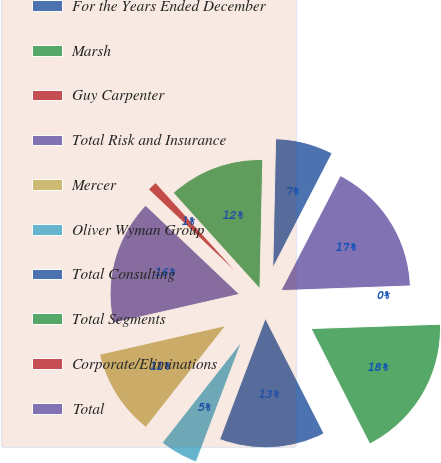Convert chart. <chart><loc_0><loc_0><loc_500><loc_500><pie_chart><fcel>For the Years Ended December<fcel>Marsh<fcel>Guy Carpenter<fcel>Total Risk and Insurance<fcel>Mercer<fcel>Oliver Wyman Group<fcel>Total Consulting<fcel>Total Segments<fcel>Corporate/Eliminations<fcel>Total<nl><fcel>7.24%<fcel>12.04%<fcel>1.24%<fcel>15.64%<fcel>10.84%<fcel>4.84%<fcel>13.24%<fcel>18.04%<fcel>0.04%<fcel>16.84%<nl></chart> 